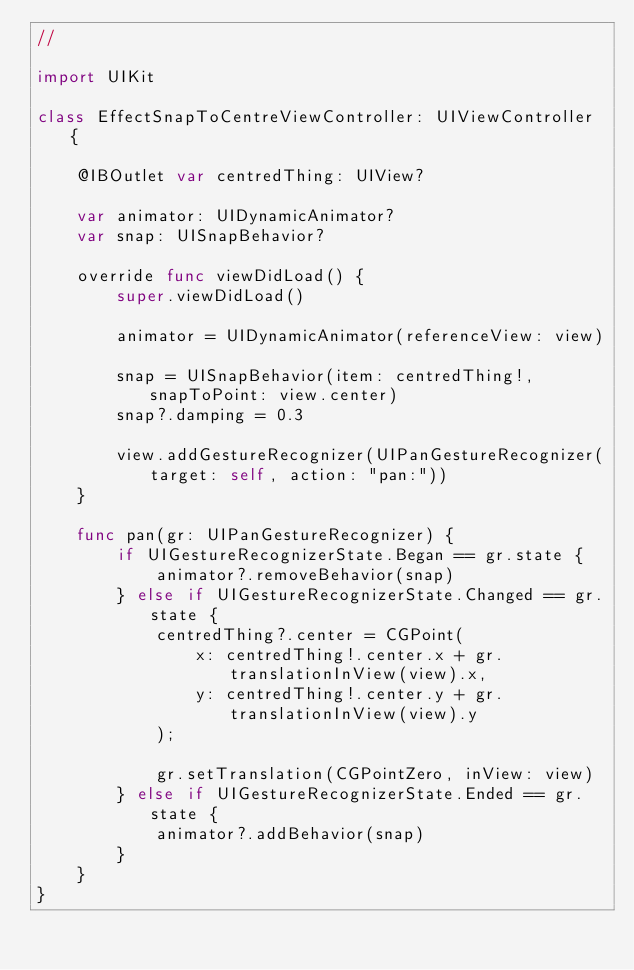Convert code to text. <code><loc_0><loc_0><loc_500><loc_500><_Swift_>//

import UIKit

class EffectSnapToCentreViewController: UIViewController {

    @IBOutlet var centredThing: UIView?
    
    var animator: UIDynamicAnimator?
    var snap: UISnapBehavior?
    
    override func viewDidLoad() {
        super.viewDidLoad()
        
        animator = UIDynamicAnimator(referenceView: view)
        
        snap = UISnapBehavior(item: centredThing!, snapToPoint: view.center)
        snap?.damping = 0.3
        
        view.addGestureRecognizer(UIPanGestureRecognizer(target: self, action: "pan:"))
    }

    func pan(gr: UIPanGestureRecognizer) {
        if UIGestureRecognizerState.Began == gr.state {
            animator?.removeBehavior(snap)
        } else if UIGestureRecognizerState.Changed == gr.state {
            centredThing?.center = CGPoint(
                x: centredThing!.center.x + gr.translationInView(view).x,
                y: centredThing!.center.y + gr.translationInView(view).y
            );

            gr.setTranslation(CGPointZero, inView: view)
        } else if UIGestureRecognizerState.Ended == gr.state {
            animator?.addBehavior(snap)
        }
    }
}
</code> 